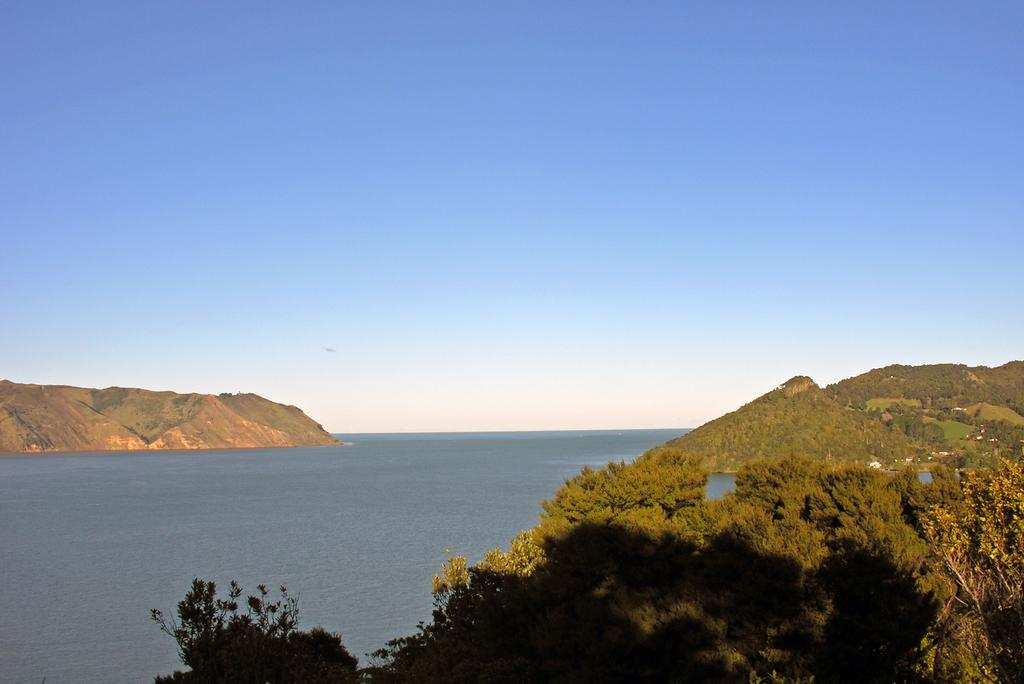What type of vegetation can be seen in the image? There are trees in the image. What else is visible besides the trees? There is water visible in the image. What is visible at the top of the image? The sky is visible at the top of the image. What is the opinion of the snail about the trees in the image? There is no snail present in the image, so it is not possible to determine its opinion about the trees. 